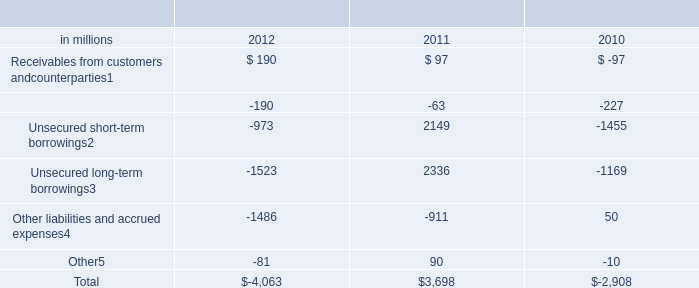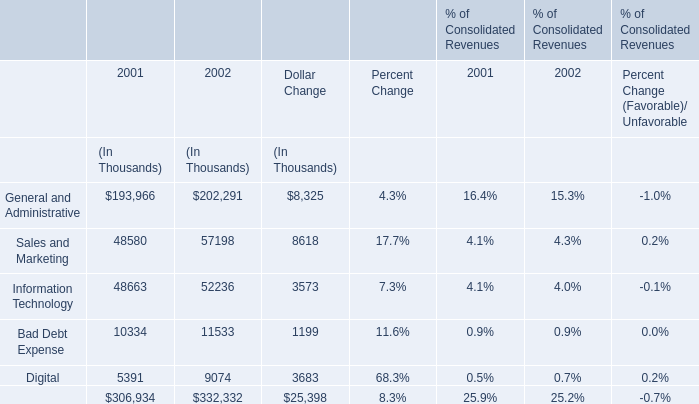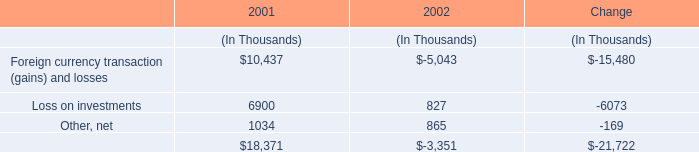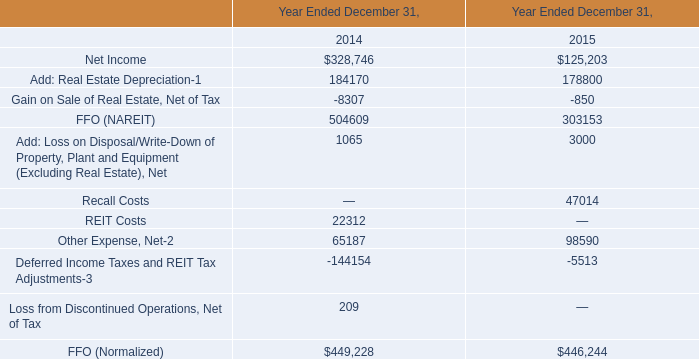What's the total amount of the Sales and Marketing for amount in the years where Loss on investments is greater than 0? (in thousand) 
Computations: (48580 + 57198)
Answer: 105778.0. 